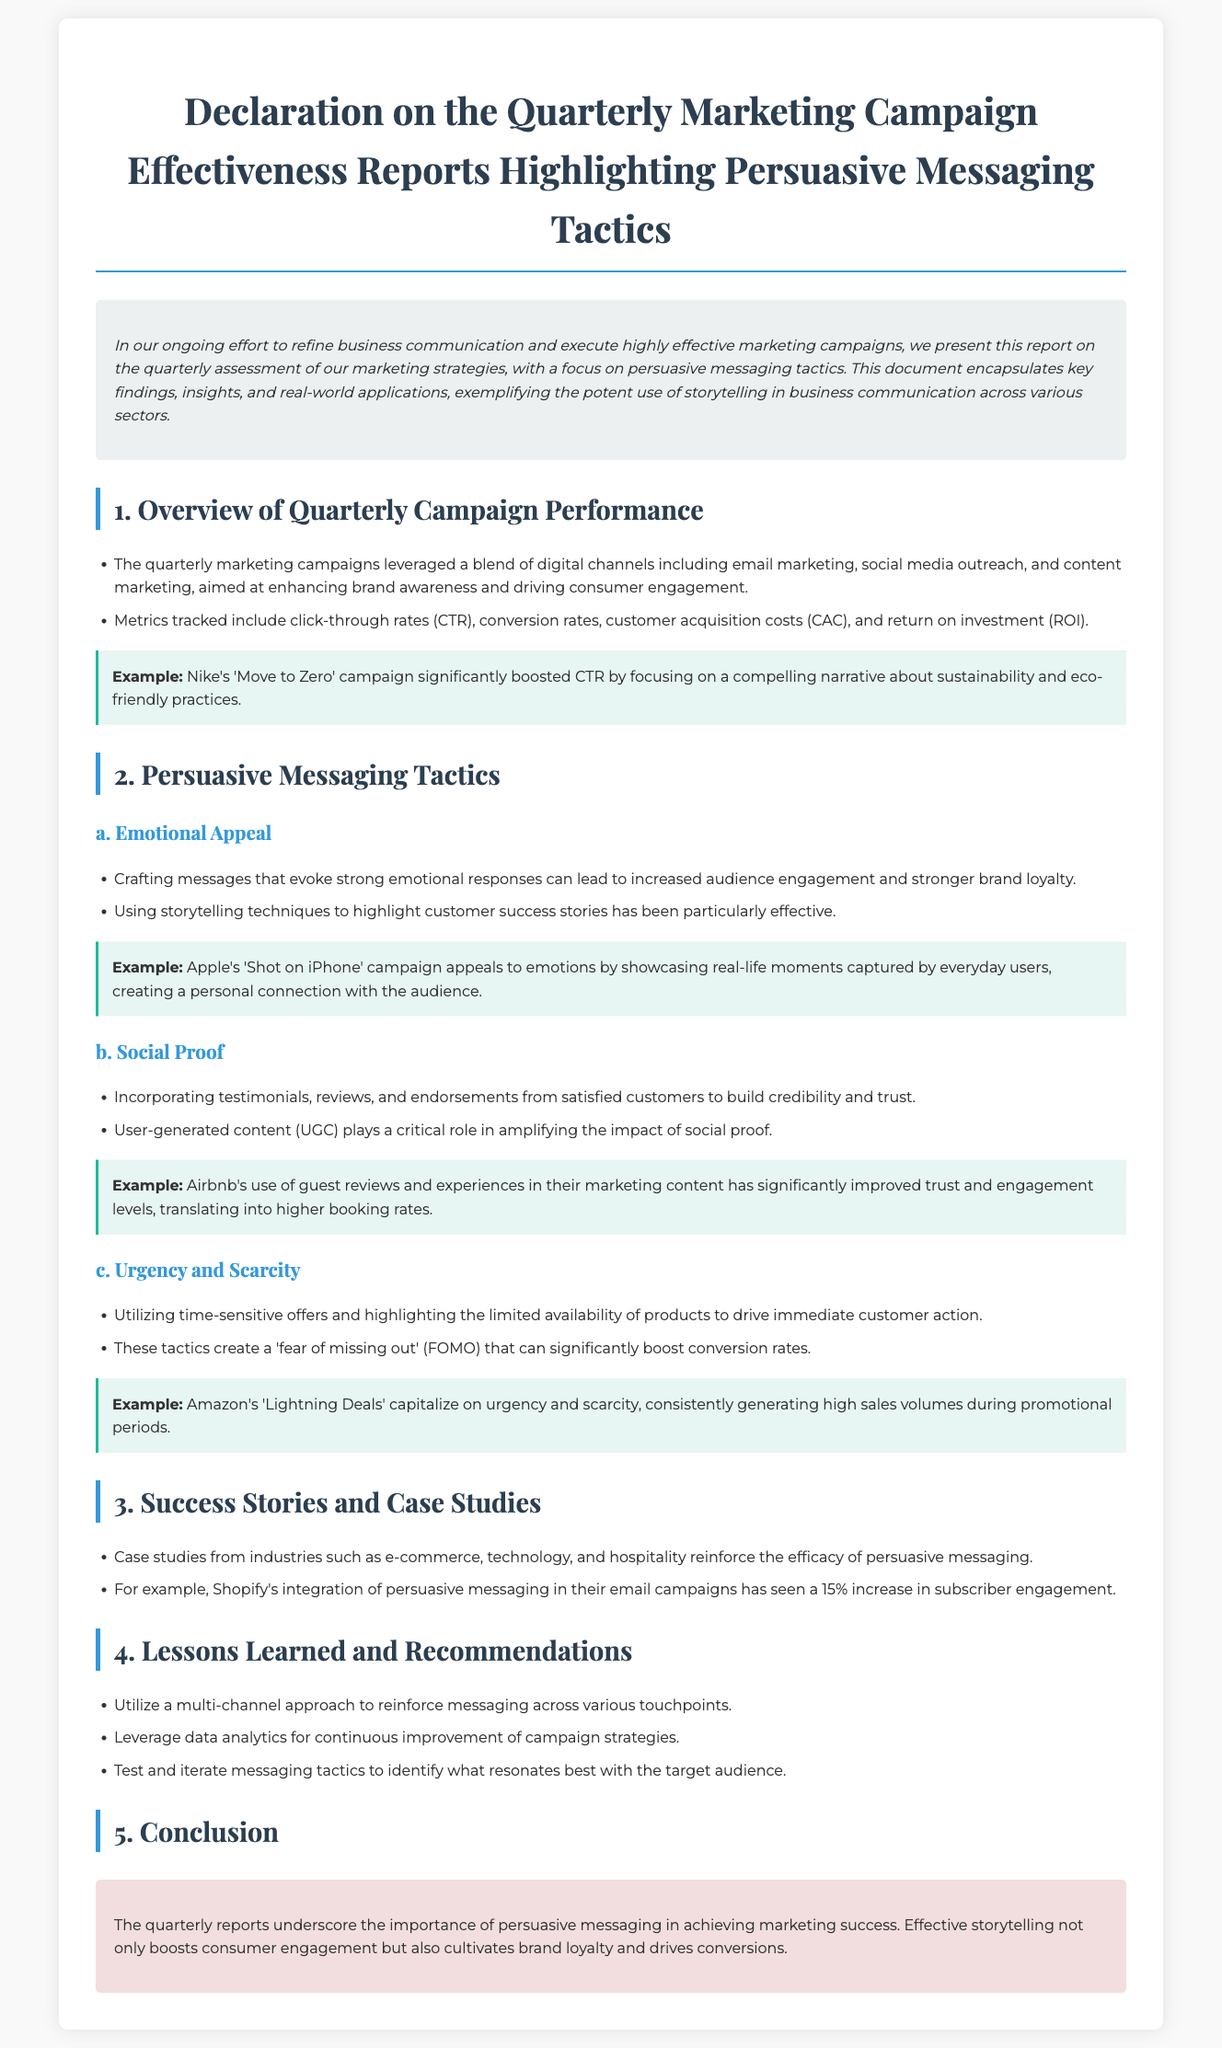what is the primary focus of the report? The report concentrates on the assessment of marketing strategies, particularly persuasive messaging tactics.
Answer: persuasive messaging tactics what campaign significantly boosted CTR? The document mentions Nike's campaign that effectively increased CTR through storytelling about sustainability.
Answer: Nike's 'Move to Zero' which emotional appeal technique is highlighted? The report describes the use of storytelling techniques to emphasize customer success stories as an emotional appeal tactic.
Answer: customer success stories what effect did Shopify's email campaigns have on engagement? According to the report, Shopify's method saw a specific percentage increase in subscriber engagement.
Answer: 15% what persuasive tactic does Amazon utilize for sales? The document states the specific tactic employed by Amazon to generate high sales volumes during promotions.
Answer: Lightning Deals how are testimonials used in marketing, according to the report? The report indicates that testimonials are incorporated to build credibility and trust.
Answer: to build credibility and trust what recommendation is made regarding campaign strategies? The report suggests leveraging specific tools for ongoing enhancement of marketing efforts.
Answer: data analytics what are the two types of marketing channels mentioned? The document refers to email marketing and social media outreach as the two marketing channels.
Answer: email marketing, social media outreach 